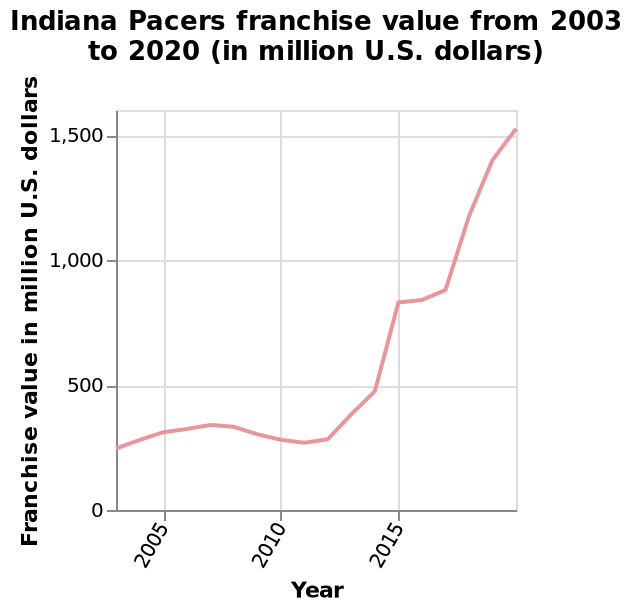<image>
How much did the value of the pacers rise from 2012 to 2015? The value of the pacers experienced a sharp rise, reaching around $800 million dollars. Was there any plateau in the value of the pacers between 2015 and 2017/18? Yes, there was a small plateau in the value of the pacers during that period. What does the y-axis measure? The y-axis measures the Franchise value in million U.S. dollars. 